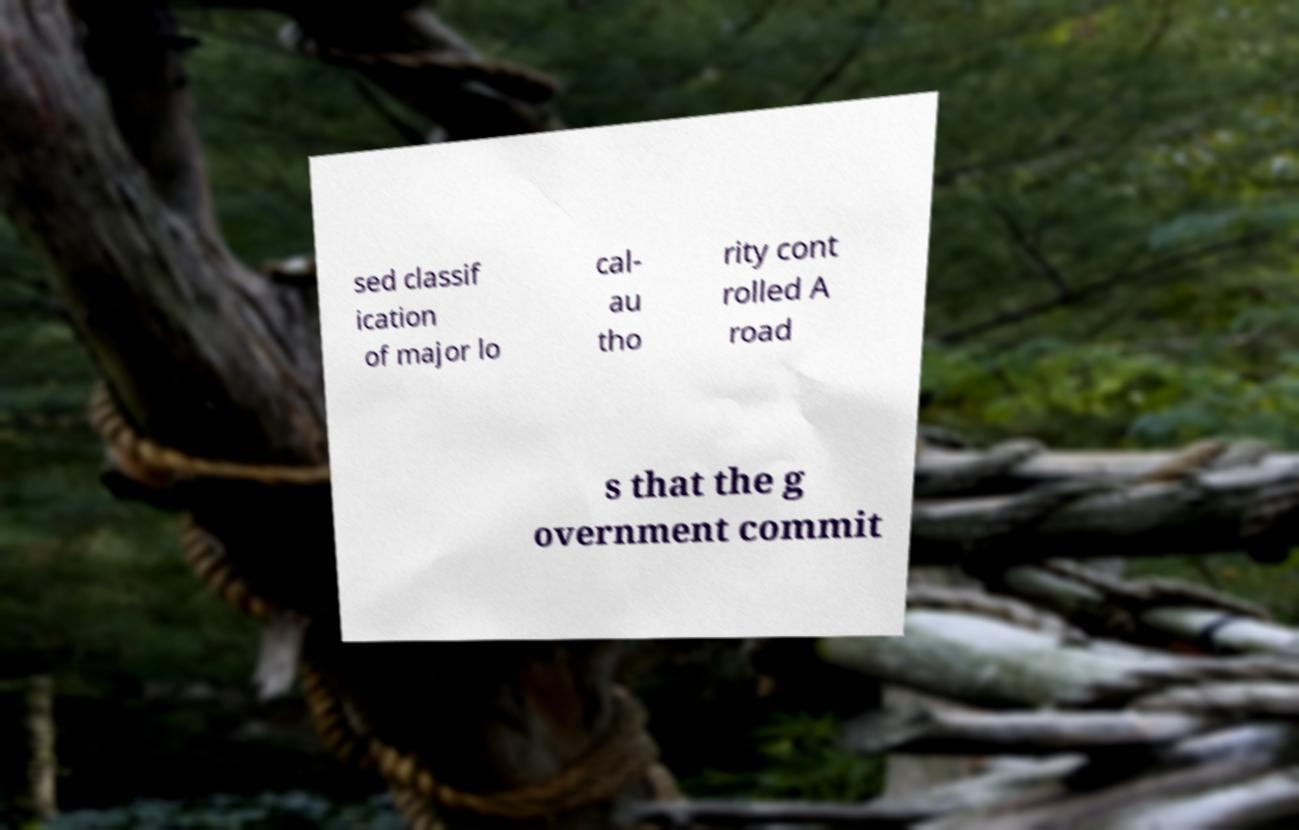Can you accurately transcribe the text from the provided image for me? sed classif ication of major lo cal- au tho rity cont rolled A road s that the g overnment commit 